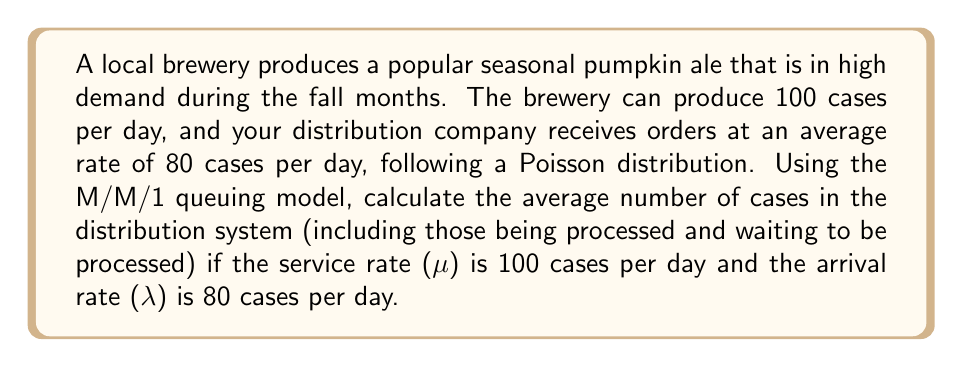Solve this math problem. To solve this problem, we'll use the M/M/1 queuing model, which is appropriate for a single-server system with Poisson arrivals and exponential service times.

Step 1: Define the variables
λ = arrival rate = 80 cases/day
μ = service rate = 100 cases/day

Step 2: Calculate the utilization factor (ρ)
The utilization factor is given by:
$$\rho = \frac{\lambda}{\mu}$$

Substituting the values:
$$\rho = \frac{80}{100} = 0.8$$

Step 3: Calculate the average number of cases in the system (L)
For an M/M/1 queue, the average number of cases in the system is given by:
$$L = \frac{\rho}{1 - \rho}$$

Substituting the calculated ρ:
$$L = \frac{0.8}{1 - 0.8} = \frac{0.8}{0.2} = 4$$

Therefore, the average number of cases in the distribution system is 4 cases.
Answer: 4 cases 